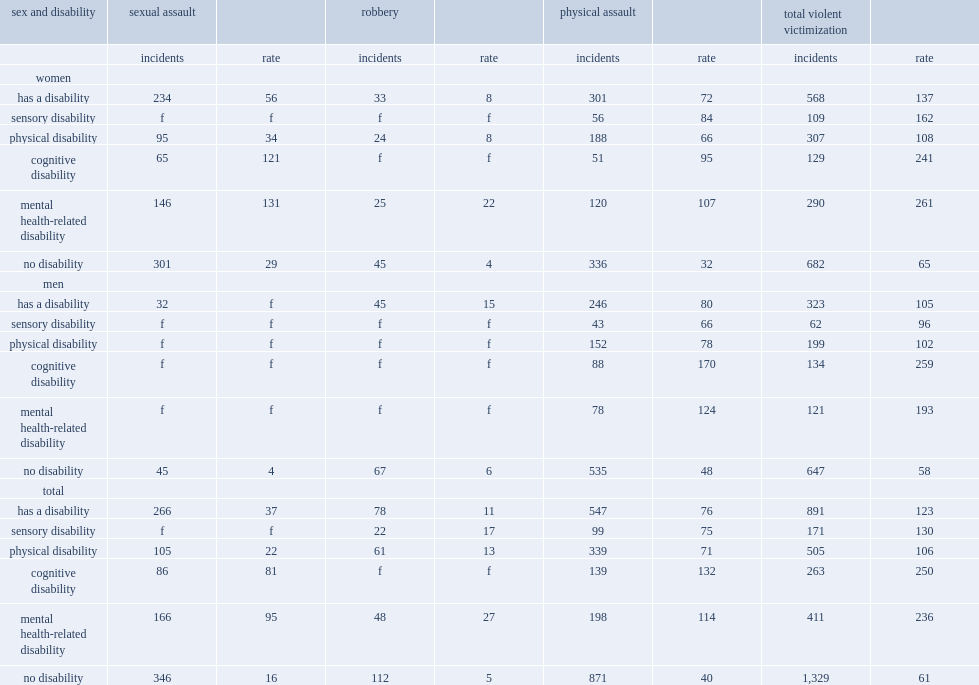Among canadians with a disability, how many times was the rate of violent victimization in the 12 months preceding the survey as high when compared to those who did not report a disability? 2.016393. How many incidents of violent victimization for every 1,000 women 15 years of age and older with a disability? 137.0. How many incidents of violent victimization for every 1,000 women 15 years of age and older without a disability? 65.0. How many incidents of violent victimization for every 1,000 women 15 years of age and older with a disability? 105.0. How many incidents of violent victimization for every 1,000 women 15 years of age and older without a disability? 58.0. 